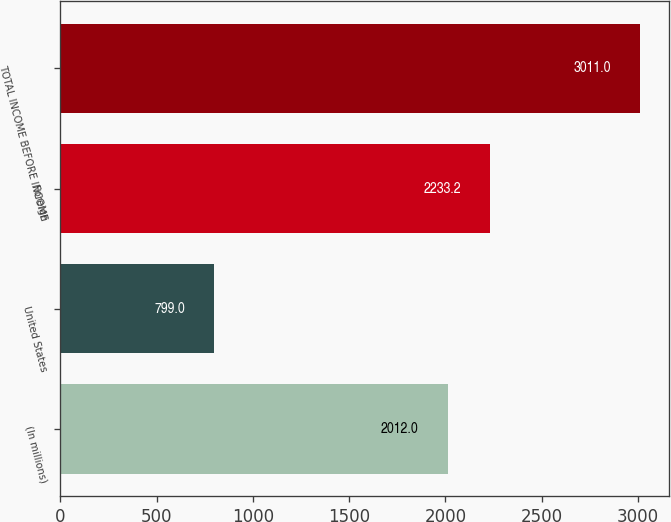Convert chart. <chart><loc_0><loc_0><loc_500><loc_500><bar_chart><fcel>(In millions)<fcel>United States<fcel>Foreign<fcel>TOTAL INCOME BEFORE INCOME<nl><fcel>2012<fcel>799<fcel>2233.2<fcel>3011<nl></chart> 